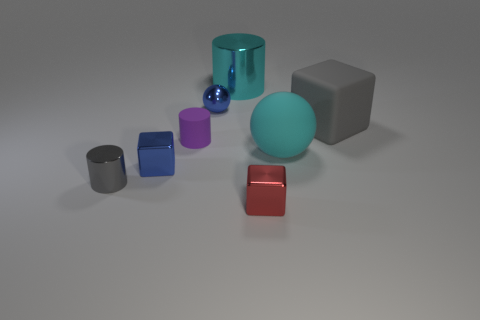What color is the other big object that is the same shape as the purple object?
Offer a terse response. Cyan. Is the color of the tiny metal cylinder the same as the matte block?
Your response must be concise. Yes. What is the material of the thing that is the same color as the small shiny cylinder?
Give a very brief answer. Rubber. Do the purple object and the red object have the same material?
Provide a succinct answer. No. What number of other objects have the same material as the small gray thing?
Ensure brevity in your answer.  4. There is a big cylinder that is made of the same material as the tiny blue block; what is its color?
Your answer should be compact. Cyan. What is the shape of the cyan matte object?
Make the answer very short. Sphere. What material is the cyan object that is in front of the gray rubber block?
Give a very brief answer. Rubber. Is there a shiny thing of the same color as the large rubber sphere?
Ensure brevity in your answer.  Yes. What is the shape of the red metal object that is the same size as the purple matte object?
Your answer should be very brief. Cube. 